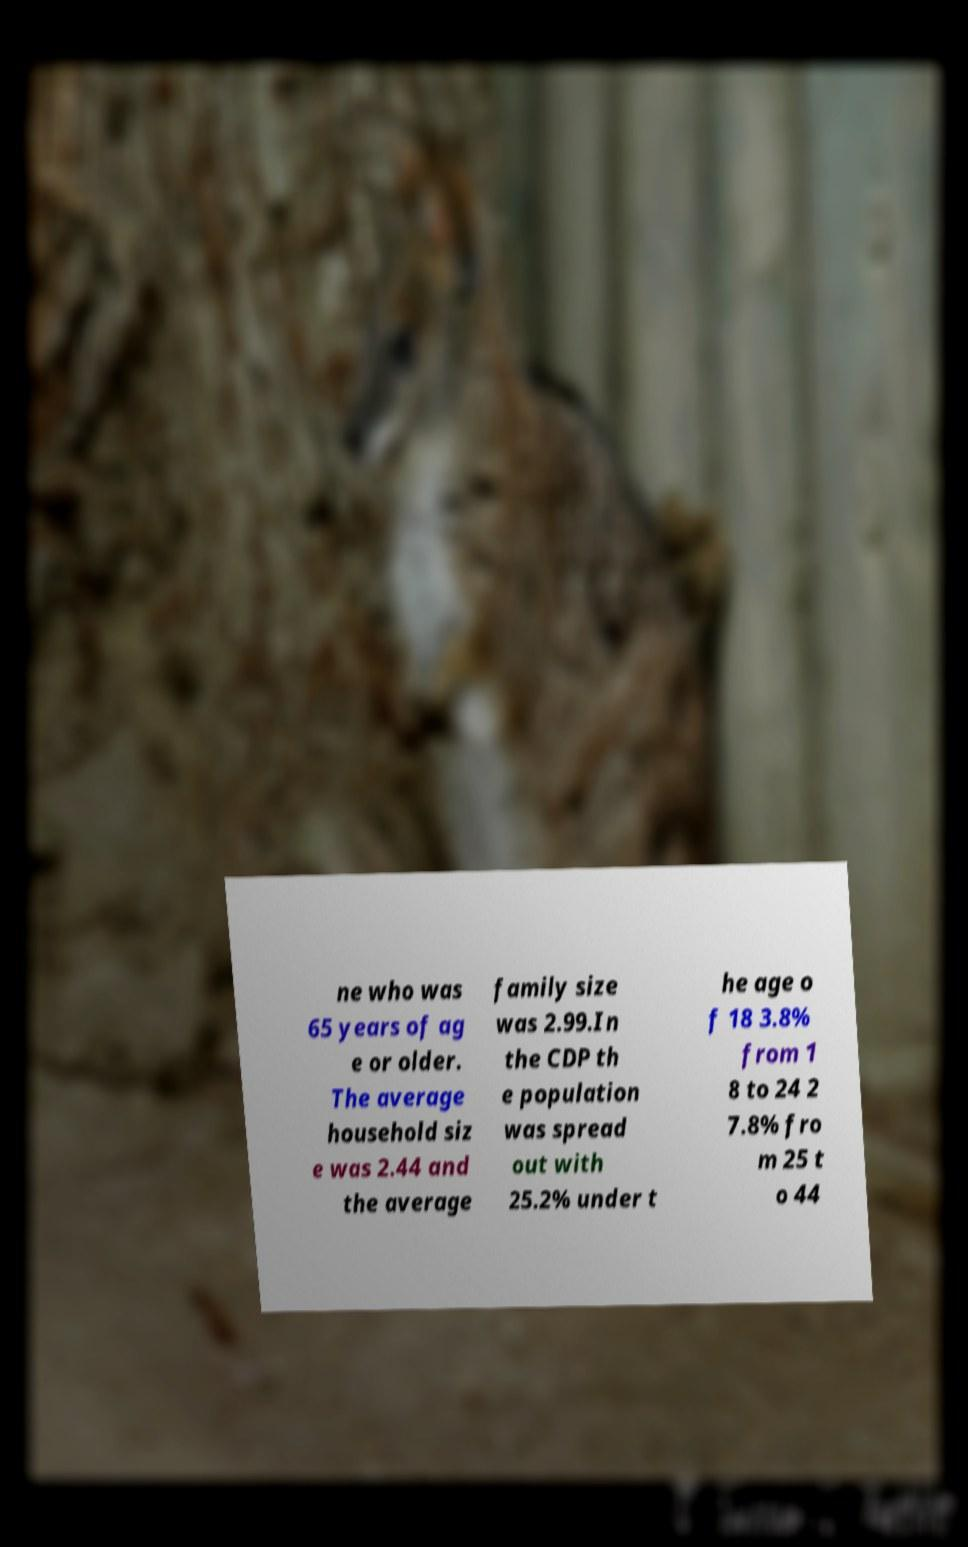Can you accurately transcribe the text from the provided image for me? ne who was 65 years of ag e or older. The average household siz e was 2.44 and the average family size was 2.99.In the CDP th e population was spread out with 25.2% under t he age o f 18 3.8% from 1 8 to 24 2 7.8% fro m 25 t o 44 